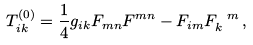Convert formula to latex. <formula><loc_0><loc_0><loc_500><loc_500>T ^ { ( 0 ) } _ { i k } = \frac { 1 } { 4 } g _ { i k } F _ { m n } F ^ { m n } - F _ { i m } F _ { k } ^ { \ m } \, ,</formula> 